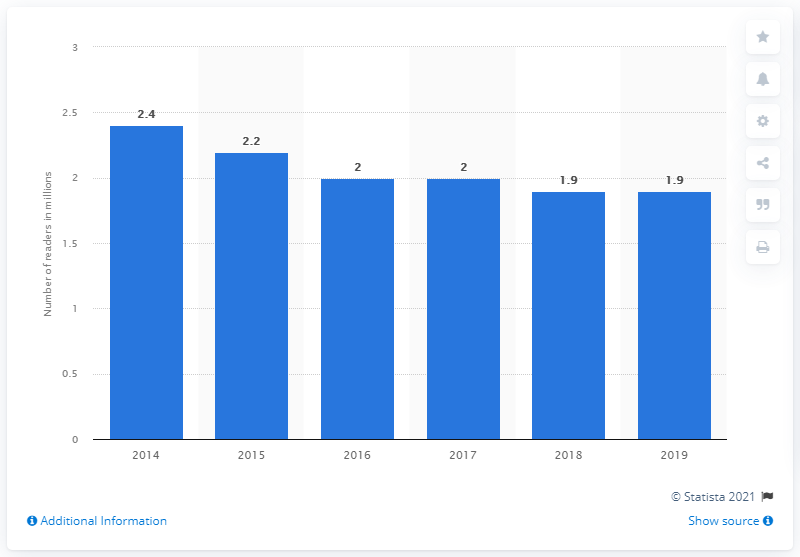List a handful of essential elements in this visual. In 2014, the daily readers of La Repubblica were 2,400. In 2019, the daily number of readers of La Repubblica was 1.9 million. 